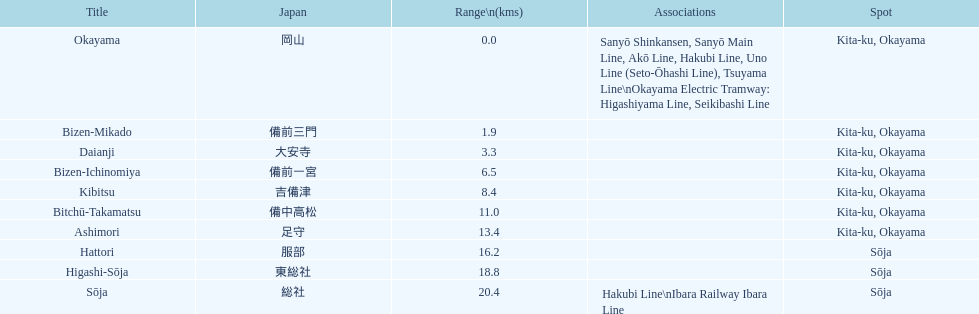Name only the stations that have connections to other lines. Okayama, Sōja. 